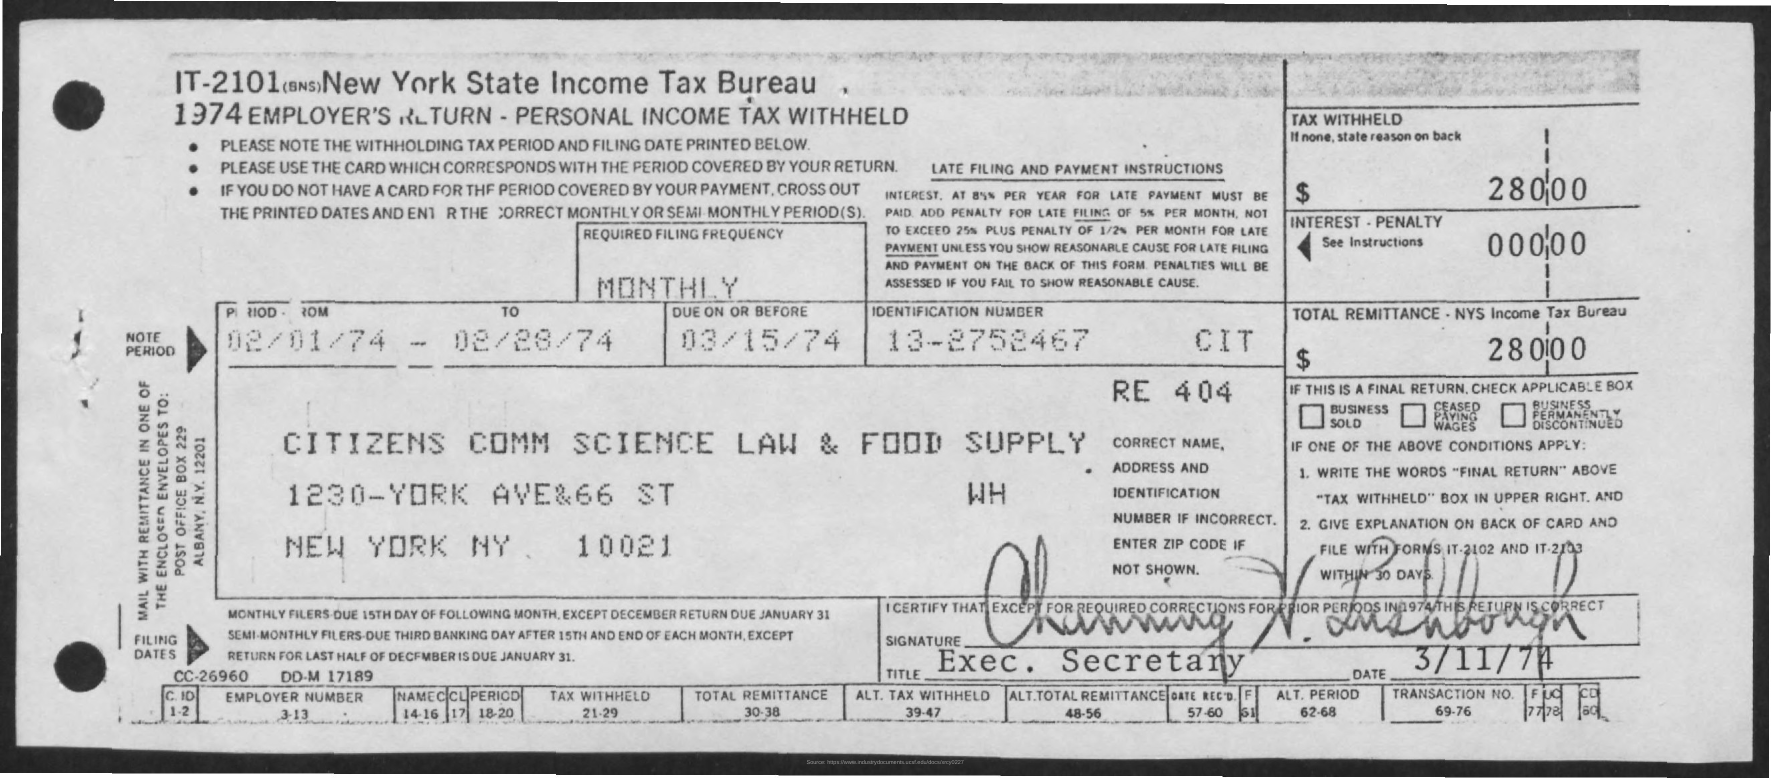Highlight a few significant elements in this photo. What is the identification number? It is 13-2752467... The amount of tax withheld is $280,000. The date from February 28, 1974, is known as the period (To). The interest and penalty amount is $0.00. The due date is March 15th, 1974. 